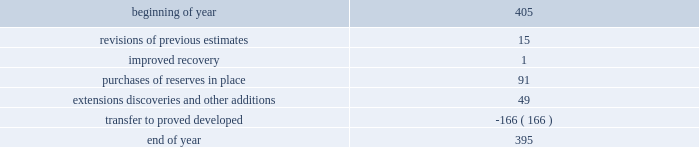For the estimates of our oil sands mining reserves has 33 years of experience in petroleum engineering and has conducted surface mineable oil sands evaluations since 1986 .
He is a member of spe , having served as regional director from 1998 through 2001 and is a registered practicing professional engineer in the province of alberta .
Audits of estimates third-party consultants are engaged to provide independent estimates for fields that comprise 80 percent of our total proved reserves over a rolling four-year period for the purpose of auditing the in-house reserve estimates .
We met this goal for the four-year period ended december 31 , 2011 .
We established a tolerance level of 10 percent such that initial estimates by the third-party consultants are accepted if they are within 10 percent of our internal estimates .
Should the third-party consultants 2019 initial analysis fail to reach our tolerance level , both our team and the consultants re-examine the information provided , request additional data and refine their analysis if appropriate .
This resolution process is continued until both estimates are within 10 percent .
This process did not result in significant changes to our reserve estimates in 2011 or 2009 .
There were no third-party audits performed in 2010 .
During 2011 , netherland , sewell & associates , inc .
( 201cnsai 201d ) prepared a certification of december 31 , 2010 reserves for the alba field in equatorial guinea .
The nsai summary report is filed as an exhibit to this annual report on form 10-k .
The senior members of the nsai team have over 50 years of industry experience between them , having worked for large , international oil and gas companies before joining nsai .
The team lead has a master of science in mechanical engineering and is a member of spe .
The senior technical advisor has a bachelor of science degree in geophysics and is a member of the society of exploration geophysicists , the american association of petroleum geologists and the european association of geoscientists and engineers .
Both are licensed in the state of texas .
Ryder scott company ( 201cryder scott 201d ) performed audits of several of our fields in 2011 and 2009 .
Their summary report on audits performed in 2011 is filed as an exhibit to this annual report on form 10-k .
The team lead for ryder scott has over 20 years of industry experience , having worked for a major international oil and gas company before joining ryder scott .
He has a bachelor of science degree in mechanical engineering , is a member of spe and is a registered professional engineer in the state of texas .
The corporate reserves group also performs separate , detailed technical reviews of reserve estimates for significant fields that were acquired recently or for properties with other indicators such as excessively short or long lives , performance above or below expectations or changes in economic or operating conditions .
Changes in proved undeveloped reserves as of december 31 , 2011 , 395 mmboe of proved undeveloped reserves were reported , a decrease of 10 mmboe from december 31 , 2010 .
The table shows changes in total proved undeveloped reserves for 2011: .
Significant additions to proved undeveloped reserves during 2011 include 91 mmboe due to acreage acquisition in the eagle ford shale , 26 mmboe related to anadarko woodford shale development , 10 mmboe for development drilling in the bakken shale play and 8 mmboe for additional drilling in norway .
Additionally , 139 mmboe were transferred from proved undeveloped to proved developed reserves due to startup of the jackpine upgrader expansion in canada .
Costs incurred in 2011 , 2010 and 2009 relating to the development of proved undeveloped reserves , were $ 1107 million , $ 1463 million and $ 792 million .
Projects can remain in proved undeveloped reserves for extended periods in certain situations such as behind-pipe zones where reserves will not be accessed until the primary producing zone depletes , large development projects which take more than five years to complete , and the timing of when additional gas compression is needed .
Of the 395 mmboe of proved undeveloped reserves at year end 2011 , 34 percent of the volume is associated with projects that have been included in proved reserves for more than five years .
The majority of this volume is related to a compression project in equatorial guinea that was sanctioned by our board of directors in 2004 and is expected to be completed by 2016 .
Performance of this field has exceeded expectations , and estimates of initial dry gas in place increased by roughly 10 percent between 2004 and 2010 .
Production is not expected to experience a natural decline from facility-limited plateau production until 2014 , or possibly 2015 .
The timing of the installation of compression is being driven by the reservoir performance. .
By how much did total proved undeveloped reserves decrease during 2011? 
Computations: ((395 - 405) / 405)
Answer: -0.02469. 